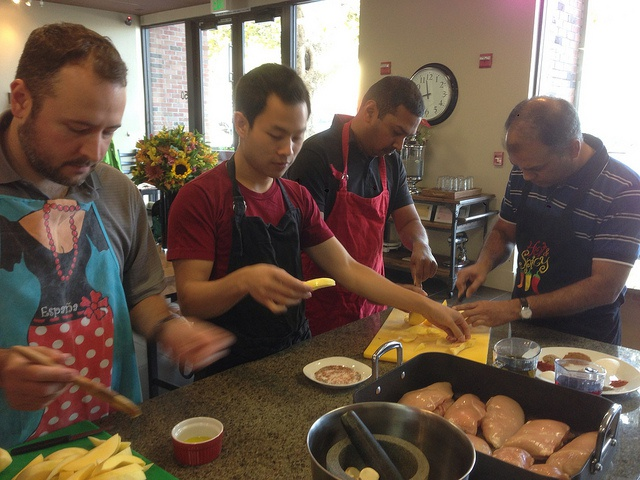Describe the objects in this image and their specific colors. I can see people in tan, maroon, black, and gray tones, dining table in tan, maroon, black, and gray tones, people in tan, black, maroon, and brown tones, people in tan, black, gray, and maroon tones, and people in tan, black, maroon, and gray tones in this image. 